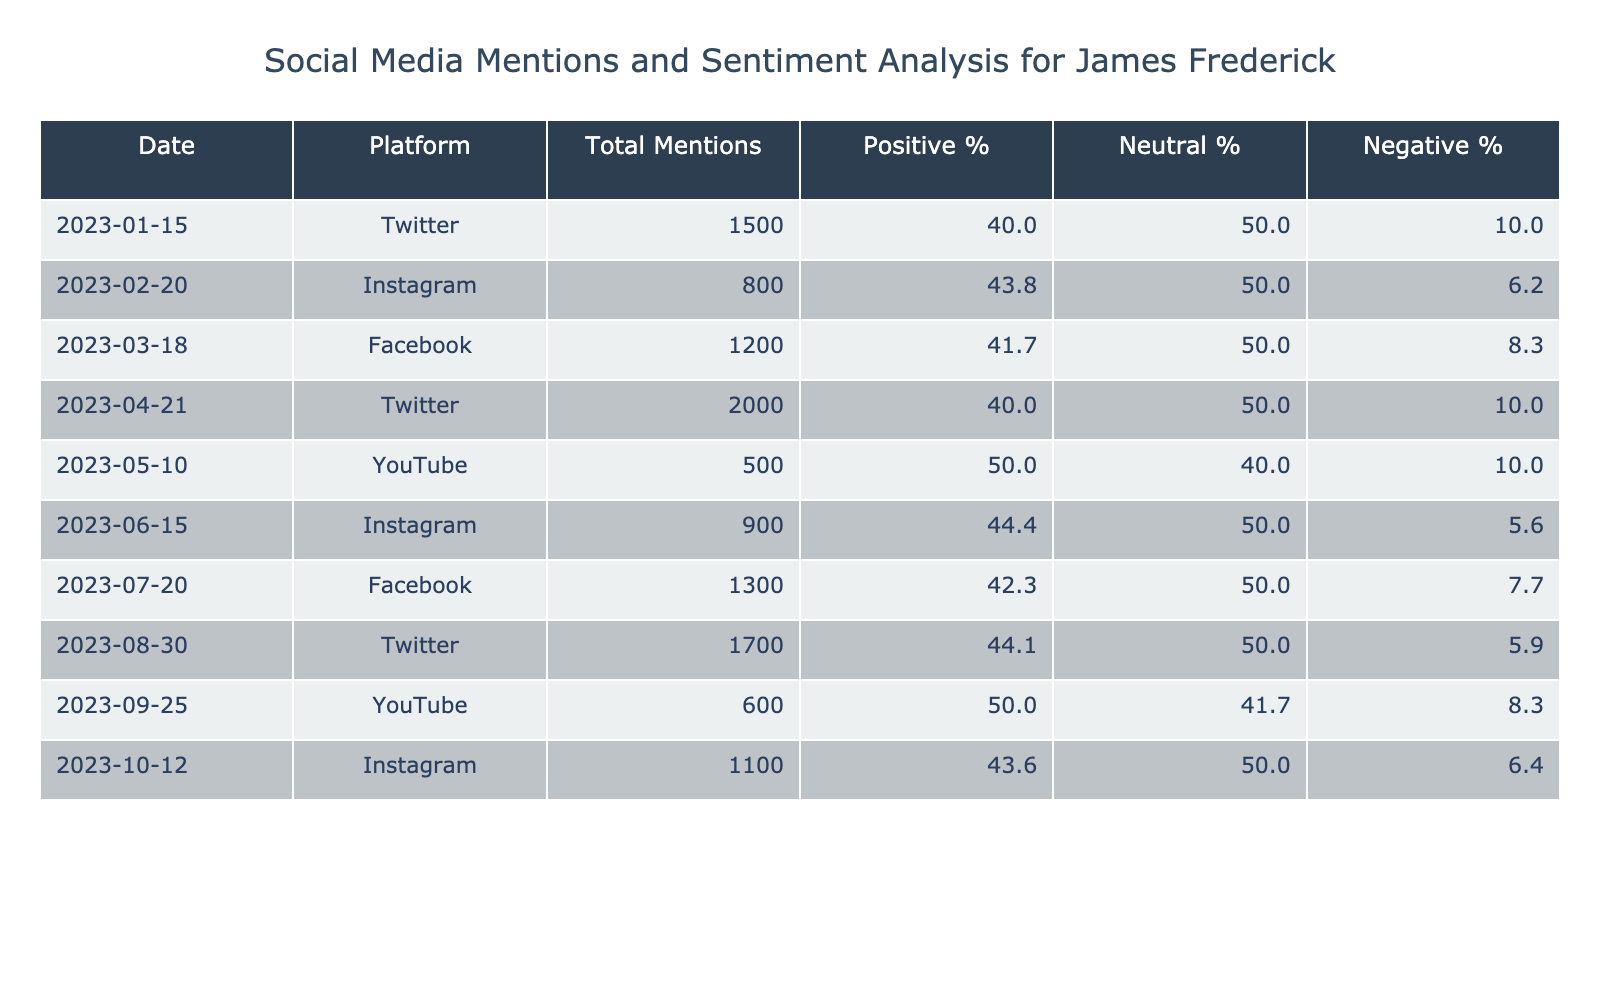What was the highest number of mentions in a single month for James Frederick? Looking at the 'Total Mentions' column, the highest value is 2000 in April 2023.
Answer: 2000 On which platform did James Frederick receive the most positive sentiment in June 2023? In June 2023, Instagram had 400 positive sentiments, which is the highest mentioned for that month compared to other platforms.
Answer: Instagram What is the percentage of negative sentiment for mentions in March 2023? For March 2023, the Negative Sentiment is 100. The Total Mentions are 1200, so the percentage is (100/1200)*100 = 8.3%.
Answer: 8.3% Which platform had the lowest percentage of positive sentiment? By checking the 'Positive %' values, YouTube in May 2023 has the lowest at 50%.
Answer: YouTube What was the average number of mentions across all platforms and months? To calculate the average, sum all Total Mentions (1500 + 800 + 1200 + 2000 + 500 + 900 + 1300 + 1700 + 600 + 1100 = 10300) and divide by 10 (the number of entries), resulting in an average of 1030.
Answer: 1030 Is there any month where the negative sentiment was lower than 5%? Checking the 'Negative %' for all months, only Instagram in June 2023 has a negative sentiment percentage of 5.6% (rounded), which is higher than 5%. Hence, the answer is no.
Answer: No What is the total neutral sentiment recorded for July? The neutral sentiment for July 2023 is 650 as per the table under the respective column for that month.
Answer: 650 In which month did James Frederick's total mentions exceed 1500 on Twitter for the first time? Referring to the 'Total Mentions,' the first time Twitter exceeds 1500 is in April 2023 with 2000 mentions.
Answer: April 2023 How does the sentiment distribution look for Instagram mentions in October 2023? For October 2023, the Positive Sentiment is 480, Neutral is 550, and Negative is 70. This reflects a more neutral sentiment distribution with a good positive count.
Answer: Mostly neutral 